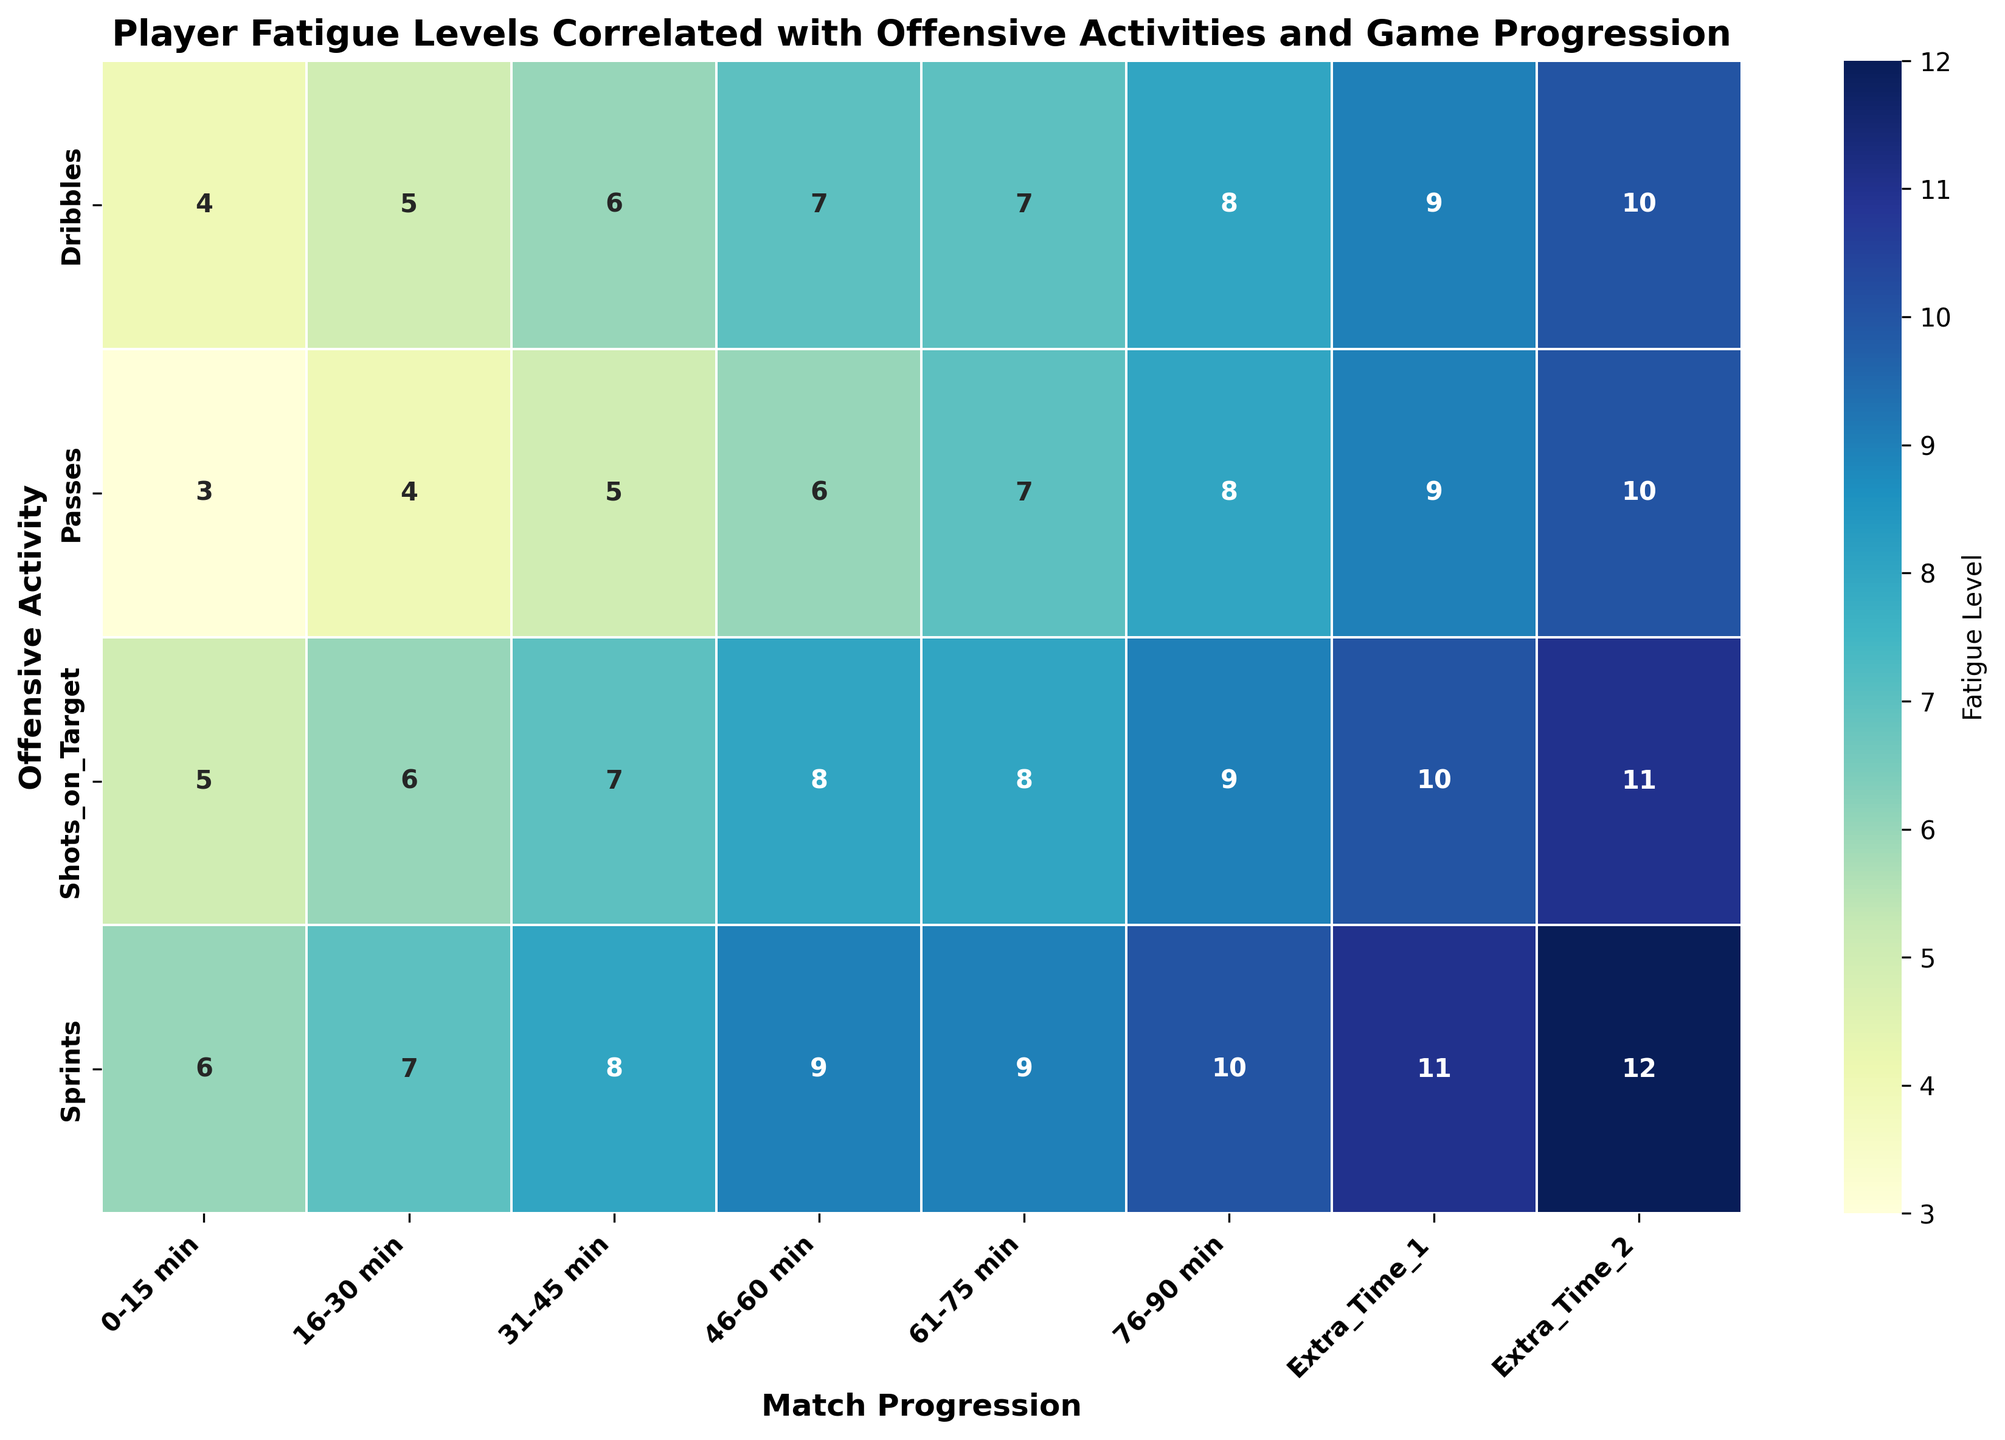What is the Player Fatigue Level during the period 31-45 min for Dribbles? The period 31-45 min corresponds to the "Dribbles" row and "31-45 min" column in the heatmap. Find the intersection value of 6.
Answer: 6 Which Offensive Activity shows the highest Player Fatigue Level during the Extra Time 2 period? Extra Time 2 corresponds to the last column in the heatmap. The highest Player Fatigue Level in this column is 12, which is for "Sprints".
Answer: Sprints What is the difference between Player Fatigue Level of Shots on Target between the periods 0-15 min and 76-90 min? The value for Shots on Target in 0-15 min is 5, and for 76-90 min it is 9. The difference is 9 - 5 = 4.
Answer: 4 Which period shows the least Player Fatigue Level for Passes? Identify the minimum value in the "Passes" row across the different periods. The least value is 3, which corresponds to the 0-15 min period.
Answer: 0-15 min How does the Player Fatigue Level trend for Sprints from 0-15 min to Extra Time 2? Observing the Sprints row, the Player Fatigue Level increases progressively from 6 in 0-15 min to 12 in Extra Time 2.
Answer: Increasing What is the average Player Fatigue Level for Dribbles and Shots on Target during 46-60 min? For 46-60 min, Dribbles is 7 and Shots on Target is 8. The average is (7 + 8) / 2 = 7.5.
Answer: 7.5 During which period do Passes have the highest Player Fatigue Level, and what is the value? Check the "Passes" row to find the maximum value, which is 10 during Extra Time 2.
Answer: Extra Time 2, 10 Compare the Player Fatigue Level of Sprints and Passes during the period 16-30 min. Which activity has higher fatigue? For 16-30 min, Sprints have a value of 7 and Passes have 4. Sprints is higher.
Answer: Sprints What's the total Player Fatigue Level for all Offensive Activities during Extra Time 1? Sum the values for Shots on Target (10), Dribbles (9), Sprints (11), and Passes (9). Total = 10 + 9 + 11 + 9 = 39.
Answer: 39 Which Offensive Activity has the smallest increase in Player Fatigue Level from 31-45 min to 46-60 min? Compare the differences: Shots on Target (8-7=1), Dribbles (7-6=1), Sprints (9-8=1), and Passes (6-5=1). All are equal with an increase of 1.
Answer: All activities 